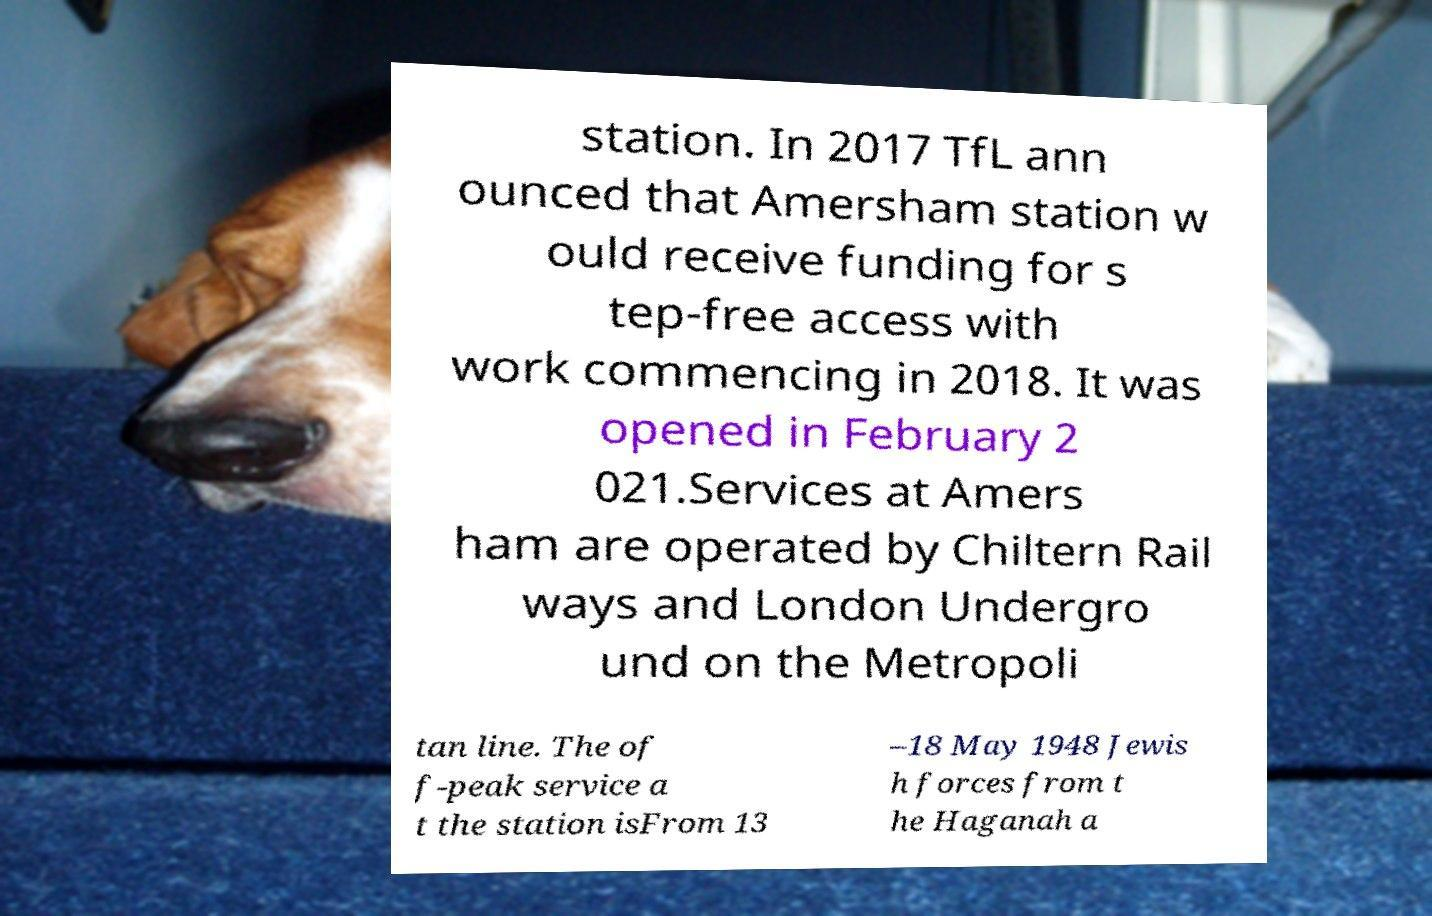Please identify and transcribe the text found in this image. station. In 2017 TfL ann ounced that Amersham station w ould receive funding for s tep-free access with work commencing in 2018. It was opened in February 2 021.Services at Amers ham are operated by Chiltern Rail ways and London Undergro und on the Metropoli tan line. The of f-peak service a t the station isFrom 13 –18 May 1948 Jewis h forces from t he Haganah a 